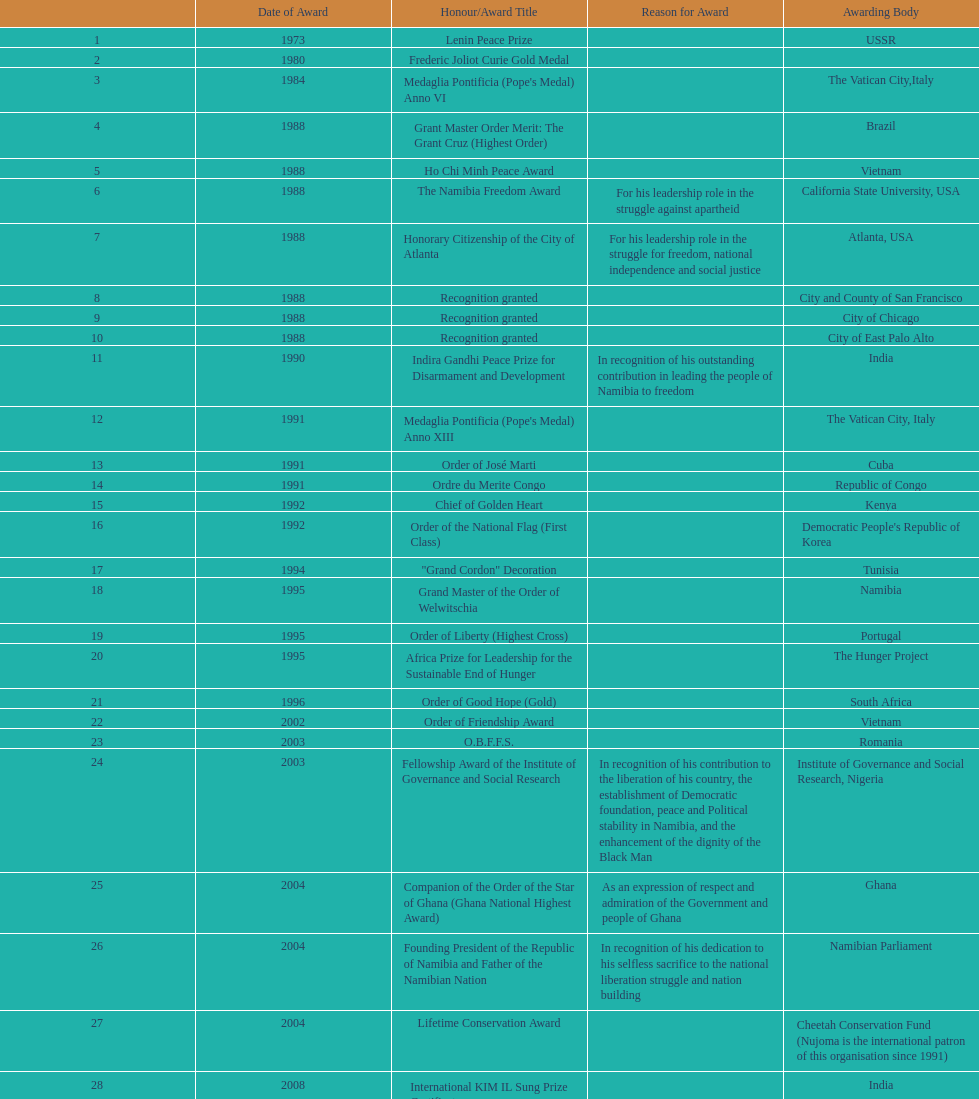Did nujoma win the o.b.f.f.s. award in romania or ghana? Romania. 